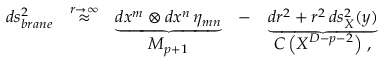Convert formula to latex. <formula><loc_0><loc_0><loc_500><loc_500>\begin{array} { c c c c c } { { d s _ { b r a n e } ^ { 2 } } } & { { \stackrel { r \to \infty } { \approx } } } & { { \underbrace { d x ^ { m } \otimes d x ^ { n } \, \eta _ { m n } } } } & { - } & { { \underbrace { d r ^ { 2 } + r ^ { 2 } \, d s _ { X } ^ { 2 } ( y ) } } } \\ { \null } & { \null } & { { M _ { p + 1 } } } & { \null } & { { C \left ( X ^ { D - p - 2 } \right ) \, , } } \end{array}</formula> 